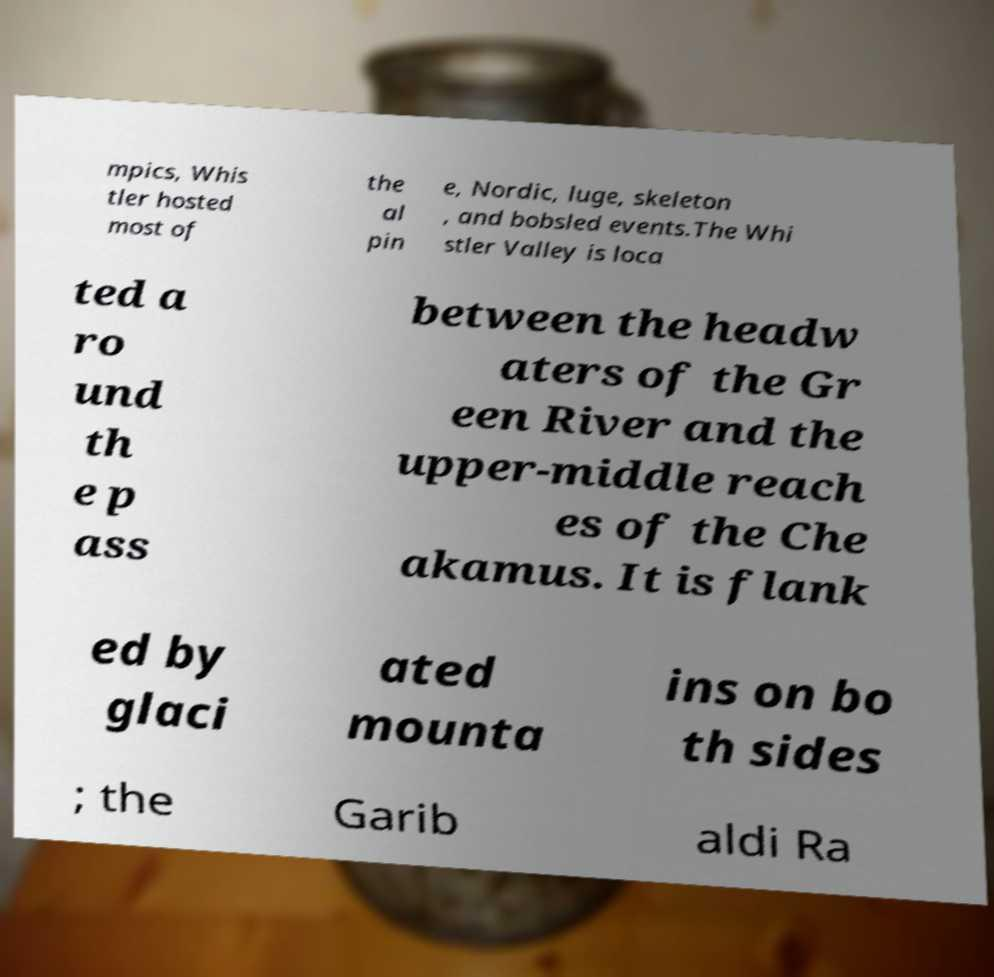Can you accurately transcribe the text from the provided image for me? mpics, Whis tler hosted most of the al pin e, Nordic, luge, skeleton , and bobsled events.The Whi stler Valley is loca ted a ro und th e p ass between the headw aters of the Gr een River and the upper-middle reach es of the Che akamus. It is flank ed by glaci ated mounta ins on bo th sides ; the Garib aldi Ra 